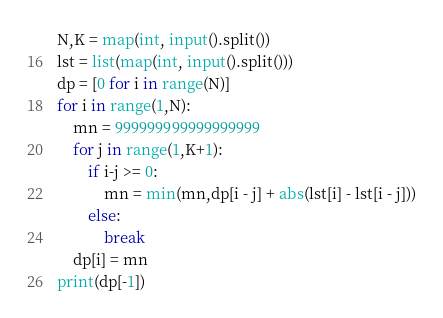<code> <loc_0><loc_0><loc_500><loc_500><_Python_>N,K = map(int, input().split())
lst = list(map(int, input().split()))
dp = [0 for i in range(N)]
for i in range(1,N):
    mn = 999999999999999999
    for j in range(1,K+1):
        if i-j >= 0:
            mn = min(mn,dp[i - j] + abs(lst[i] - lst[i - j]))
        else:
            break
    dp[i] = mn
print(dp[-1])
</code> 